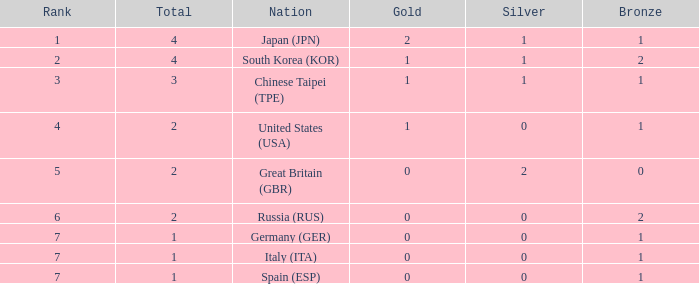What is the rank of the country with more than 2 medals, and 2 gold medals? 1.0. 